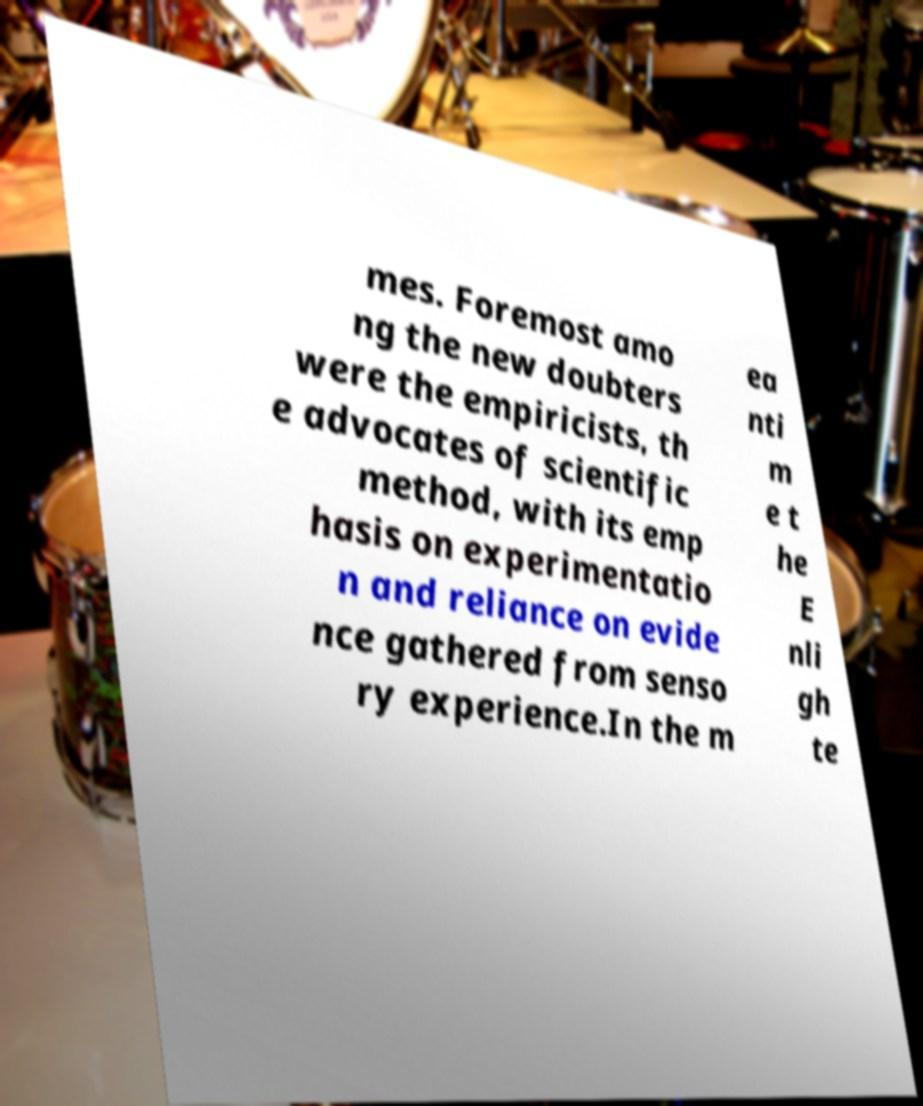Can you read and provide the text displayed in the image?This photo seems to have some interesting text. Can you extract and type it out for me? mes. Foremost amo ng the new doubters were the empiricists, th e advocates of scientific method, with its emp hasis on experimentatio n and reliance on evide nce gathered from senso ry experience.In the m ea nti m e t he E nli gh te 